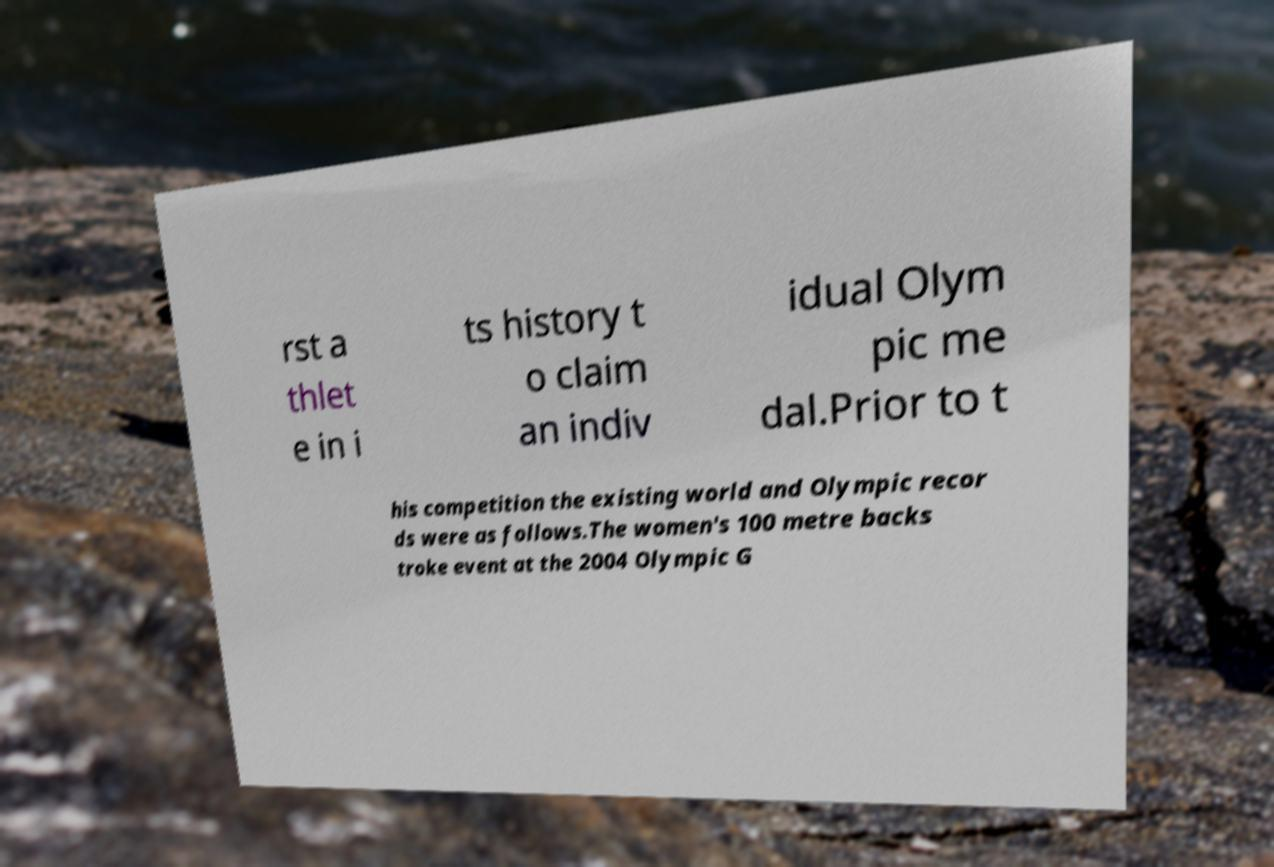Could you extract and type out the text from this image? rst a thlet e in i ts history t o claim an indiv idual Olym pic me dal.Prior to t his competition the existing world and Olympic recor ds were as follows.The women's 100 metre backs troke event at the 2004 Olympic G 